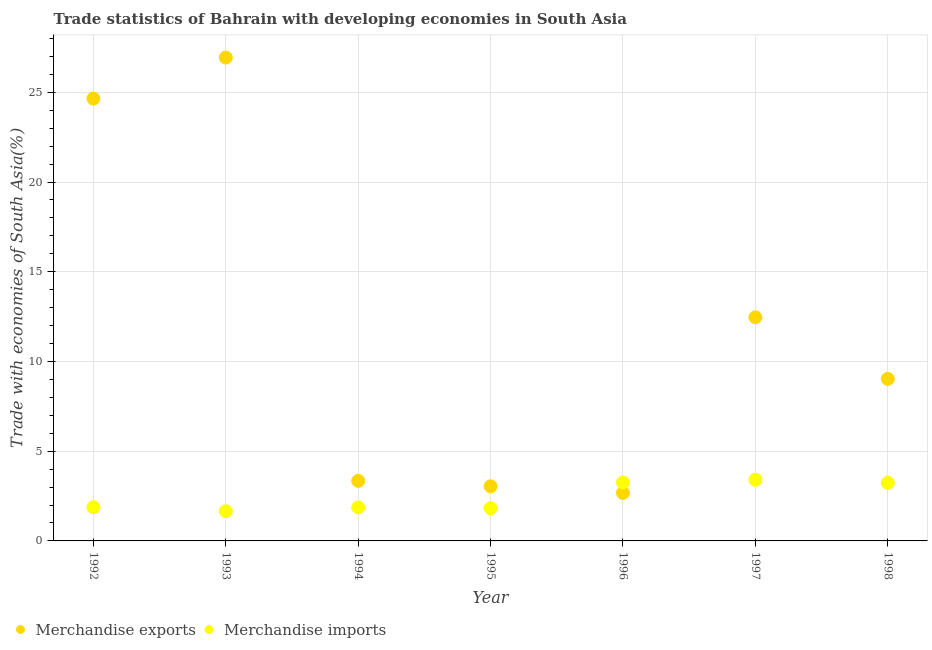How many different coloured dotlines are there?
Keep it short and to the point. 2. What is the merchandise imports in 1995?
Your answer should be very brief. 1.82. Across all years, what is the maximum merchandise exports?
Your answer should be compact. 26.94. Across all years, what is the minimum merchandise exports?
Provide a short and direct response. 2.67. What is the total merchandise exports in the graph?
Provide a short and direct response. 82.15. What is the difference between the merchandise imports in 1993 and that in 1994?
Keep it short and to the point. -0.21. What is the difference between the merchandise imports in 1997 and the merchandise exports in 1992?
Offer a very short reply. -21.24. What is the average merchandise exports per year?
Your answer should be very brief. 11.74. In the year 1993, what is the difference between the merchandise imports and merchandise exports?
Ensure brevity in your answer.  -25.28. What is the ratio of the merchandise exports in 1996 to that in 1997?
Keep it short and to the point. 0.21. Is the merchandise imports in 1995 less than that in 1997?
Keep it short and to the point. Yes. What is the difference between the highest and the second highest merchandise imports?
Provide a short and direct response. 0.15. What is the difference between the highest and the lowest merchandise exports?
Make the answer very short. 24.26. In how many years, is the merchandise exports greater than the average merchandise exports taken over all years?
Provide a succinct answer. 3. Does the merchandise exports monotonically increase over the years?
Offer a terse response. No. Is the merchandise exports strictly greater than the merchandise imports over the years?
Give a very brief answer. No. Does the graph contain grids?
Your response must be concise. Yes. Where does the legend appear in the graph?
Your answer should be very brief. Bottom left. How are the legend labels stacked?
Offer a terse response. Horizontal. What is the title of the graph?
Make the answer very short. Trade statistics of Bahrain with developing economies in South Asia. What is the label or title of the Y-axis?
Offer a very short reply. Trade with economies of South Asia(%). What is the Trade with economies of South Asia(%) in Merchandise exports in 1992?
Make the answer very short. 24.65. What is the Trade with economies of South Asia(%) in Merchandise imports in 1992?
Your response must be concise. 1.88. What is the Trade with economies of South Asia(%) in Merchandise exports in 1993?
Make the answer very short. 26.94. What is the Trade with economies of South Asia(%) of Merchandise imports in 1993?
Provide a short and direct response. 1.65. What is the Trade with economies of South Asia(%) of Merchandise exports in 1994?
Offer a very short reply. 3.35. What is the Trade with economies of South Asia(%) in Merchandise imports in 1994?
Ensure brevity in your answer.  1.87. What is the Trade with economies of South Asia(%) in Merchandise exports in 1995?
Your answer should be very brief. 3.04. What is the Trade with economies of South Asia(%) of Merchandise imports in 1995?
Keep it short and to the point. 1.82. What is the Trade with economies of South Asia(%) in Merchandise exports in 1996?
Your answer should be very brief. 2.67. What is the Trade with economies of South Asia(%) in Merchandise imports in 1996?
Ensure brevity in your answer.  3.26. What is the Trade with economies of South Asia(%) of Merchandise exports in 1997?
Ensure brevity in your answer.  12.46. What is the Trade with economies of South Asia(%) in Merchandise imports in 1997?
Your answer should be compact. 3.41. What is the Trade with economies of South Asia(%) of Merchandise exports in 1998?
Your response must be concise. 9.03. What is the Trade with economies of South Asia(%) in Merchandise imports in 1998?
Keep it short and to the point. 3.24. Across all years, what is the maximum Trade with economies of South Asia(%) of Merchandise exports?
Provide a succinct answer. 26.94. Across all years, what is the maximum Trade with economies of South Asia(%) of Merchandise imports?
Offer a very short reply. 3.41. Across all years, what is the minimum Trade with economies of South Asia(%) of Merchandise exports?
Provide a short and direct response. 2.67. Across all years, what is the minimum Trade with economies of South Asia(%) in Merchandise imports?
Offer a very short reply. 1.65. What is the total Trade with economies of South Asia(%) in Merchandise exports in the graph?
Provide a short and direct response. 82.15. What is the total Trade with economies of South Asia(%) of Merchandise imports in the graph?
Ensure brevity in your answer.  17.13. What is the difference between the Trade with economies of South Asia(%) in Merchandise exports in 1992 and that in 1993?
Offer a very short reply. -2.29. What is the difference between the Trade with economies of South Asia(%) in Merchandise imports in 1992 and that in 1993?
Provide a succinct answer. 0.23. What is the difference between the Trade with economies of South Asia(%) of Merchandise exports in 1992 and that in 1994?
Keep it short and to the point. 21.3. What is the difference between the Trade with economies of South Asia(%) of Merchandise imports in 1992 and that in 1994?
Keep it short and to the point. 0.01. What is the difference between the Trade with economies of South Asia(%) of Merchandise exports in 1992 and that in 1995?
Provide a short and direct response. 21.6. What is the difference between the Trade with economies of South Asia(%) in Merchandise imports in 1992 and that in 1995?
Offer a very short reply. 0.06. What is the difference between the Trade with economies of South Asia(%) of Merchandise exports in 1992 and that in 1996?
Your response must be concise. 21.97. What is the difference between the Trade with economies of South Asia(%) of Merchandise imports in 1992 and that in 1996?
Provide a short and direct response. -1.38. What is the difference between the Trade with economies of South Asia(%) in Merchandise exports in 1992 and that in 1997?
Provide a short and direct response. 12.19. What is the difference between the Trade with economies of South Asia(%) of Merchandise imports in 1992 and that in 1997?
Your response must be concise. -1.53. What is the difference between the Trade with economies of South Asia(%) in Merchandise exports in 1992 and that in 1998?
Provide a succinct answer. 15.62. What is the difference between the Trade with economies of South Asia(%) of Merchandise imports in 1992 and that in 1998?
Keep it short and to the point. -1.36. What is the difference between the Trade with economies of South Asia(%) of Merchandise exports in 1993 and that in 1994?
Ensure brevity in your answer.  23.59. What is the difference between the Trade with economies of South Asia(%) in Merchandise imports in 1993 and that in 1994?
Keep it short and to the point. -0.21. What is the difference between the Trade with economies of South Asia(%) in Merchandise exports in 1993 and that in 1995?
Offer a terse response. 23.89. What is the difference between the Trade with economies of South Asia(%) of Merchandise imports in 1993 and that in 1995?
Make the answer very short. -0.17. What is the difference between the Trade with economies of South Asia(%) in Merchandise exports in 1993 and that in 1996?
Offer a very short reply. 24.26. What is the difference between the Trade with economies of South Asia(%) in Merchandise imports in 1993 and that in 1996?
Your answer should be compact. -1.61. What is the difference between the Trade with economies of South Asia(%) in Merchandise exports in 1993 and that in 1997?
Ensure brevity in your answer.  14.47. What is the difference between the Trade with economies of South Asia(%) in Merchandise imports in 1993 and that in 1997?
Ensure brevity in your answer.  -1.75. What is the difference between the Trade with economies of South Asia(%) in Merchandise exports in 1993 and that in 1998?
Make the answer very short. 17.91. What is the difference between the Trade with economies of South Asia(%) in Merchandise imports in 1993 and that in 1998?
Your answer should be very brief. -1.58. What is the difference between the Trade with economies of South Asia(%) in Merchandise exports in 1994 and that in 1995?
Offer a terse response. 0.3. What is the difference between the Trade with economies of South Asia(%) of Merchandise imports in 1994 and that in 1995?
Offer a terse response. 0.05. What is the difference between the Trade with economies of South Asia(%) of Merchandise exports in 1994 and that in 1996?
Your response must be concise. 0.67. What is the difference between the Trade with economies of South Asia(%) of Merchandise imports in 1994 and that in 1996?
Your answer should be very brief. -1.39. What is the difference between the Trade with economies of South Asia(%) in Merchandise exports in 1994 and that in 1997?
Provide a short and direct response. -9.11. What is the difference between the Trade with economies of South Asia(%) of Merchandise imports in 1994 and that in 1997?
Provide a succinct answer. -1.54. What is the difference between the Trade with economies of South Asia(%) of Merchandise exports in 1994 and that in 1998?
Keep it short and to the point. -5.68. What is the difference between the Trade with economies of South Asia(%) in Merchandise imports in 1994 and that in 1998?
Provide a short and direct response. -1.37. What is the difference between the Trade with economies of South Asia(%) in Merchandise exports in 1995 and that in 1996?
Offer a very short reply. 0.37. What is the difference between the Trade with economies of South Asia(%) in Merchandise imports in 1995 and that in 1996?
Your response must be concise. -1.44. What is the difference between the Trade with economies of South Asia(%) in Merchandise exports in 1995 and that in 1997?
Offer a terse response. -9.42. What is the difference between the Trade with economies of South Asia(%) in Merchandise imports in 1995 and that in 1997?
Offer a terse response. -1.59. What is the difference between the Trade with economies of South Asia(%) of Merchandise exports in 1995 and that in 1998?
Provide a succinct answer. -5.99. What is the difference between the Trade with economies of South Asia(%) in Merchandise imports in 1995 and that in 1998?
Make the answer very short. -1.41. What is the difference between the Trade with economies of South Asia(%) in Merchandise exports in 1996 and that in 1997?
Your response must be concise. -9.79. What is the difference between the Trade with economies of South Asia(%) in Merchandise imports in 1996 and that in 1997?
Your answer should be compact. -0.15. What is the difference between the Trade with economies of South Asia(%) in Merchandise exports in 1996 and that in 1998?
Your answer should be very brief. -6.36. What is the difference between the Trade with economies of South Asia(%) in Merchandise imports in 1996 and that in 1998?
Make the answer very short. 0.02. What is the difference between the Trade with economies of South Asia(%) in Merchandise exports in 1997 and that in 1998?
Give a very brief answer. 3.43. What is the difference between the Trade with economies of South Asia(%) of Merchandise imports in 1997 and that in 1998?
Give a very brief answer. 0.17. What is the difference between the Trade with economies of South Asia(%) of Merchandise exports in 1992 and the Trade with economies of South Asia(%) of Merchandise imports in 1993?
Ensure brevity in your answer.  23. What is the difference between the Trade with economies of South Asia(%) of Merchandise exports in 1992 and the Trade with economies of South Asia(%) of Merchandise imports in 1994?
Ensure brevity in your answer.  22.78. What is the difference between the Trade with economies of South Asia(%) of Merchandise exports in 1992 and the Trade with economies of South Asia(%) of Merchandise imports in 1995?
Provide a succinct answer. 22.83. What is the difference between the Trade with economies of South Asia(%) of Merchandise exports in 1992 and the Trade with economies of South Asia(%) of Merchandise imports in 1996?
Provide a succinct answer. 21.39. What is the difference between the Trade with economies of South Asia(%) in Merchandise exports in 1992 and the Trade with economies of South Asia(%) in Merchandise imports in 1997?
Keep it short and to the point. 21.24. What is the difference between the Trade with economies of South Asia(%) in Merchandise exports in 1992 and the Trade with economies of South Asia(%) in Merchandise imports in 1998?
Give a very brief answer. 21.41. What is the difference between the Trade with economies of South Asia(%) in Merchandise exports in 1993 and the Trade with economies of South Asia(%) in Merchandise imports in 1994?
Offer a terse response. 25.07. What is the difference between the Trade with economies of South Asia(%) in Merchandise exports in 1993 and the Trade with economies of South Asia(%) in Merchandise imports in 1995?
Give a very brief answer. 25.11. What is the difference between the Trade with economies of South Asia(%) of Merchandise exports in 1993 and the Trade with economies of South Asia(%) of Merchandise imports in 1996?
Ensure brevity in your answer.  23.68. What is the difference between the Trade with economies of South Asia(%) in Merchandise exports in 1993 and the Trade with economies of South Asia(%) in Merchandise imports in 1997?
Keep it short and to the point. 23.53. What is the difference between the Trade with economies of South Asia(%) in Merchandise exports in 1993 and the Trade with economies of South Asia(%) in Merchandise imports in 1998?
Provide a short and direct response. 23.7. What is the difference between the Trade with economies of South Asia(%) of Merchandise exports in 1994 and the Trade with economies of South Asia(%) of Merchandise imports in 1995?
Ensure brevity in your answer.  1.53. What is the difference between the Trade with economies of South Asia(%) in Merchandise exports in 1994 and the Trade with economies of South Asia(%) in Merchandise imports in 1996?
Your answer should be compact. 0.09. What is the difference between the Trade with economies of South Asia(%) of Merchandise exports in 1994 and the Trade with economies of South Asia(%) of Merchandise imports in 1997?
Your answer should be compact. -0.06. What is the difference between the Trade with economies of South Asia(%) in Merchandise exports in 1994 and the Trade with economies of South Asia(%) in Merchandise imports in 1998?
Make the answer very short. 0.11. What is the difference between the Trade with economies of South Asia(%) of Merchandise exports in 1995 and the Trade with economies of South Asia(%) of Merchandise imports in 1996?
Your answer should be very brief. -0.21. What is the difference between the Trade with economies of South Asia(%) in Merchandise exports in 1995 and the Trade with economies of South Asia(%) in Merchandise imports in 1997?
Provide a succinct answer. -0.36. What is the difference between the Trade with economies of South Asia(%) in Merchandise exports in 1995 and the Trade with economies of South Asia(%) in Merchandise imports in 1998?
Your answer should be very brief. -0.19. What is the difference between the Trade with economies of South Asia(%) in Merchandise exports in 1996 and the Trade with economies of South Asia(%) in Merchandise imports in 1997?
Give a very brief answer. -0.73. What is the difference between the Trade with economies of South Asia(%) of Merchandise exports in 1996 and the Trade with economies of South Asia(%) of Merchandise imports in 1998?
Provide a succinct answer. -0.56. What is the difference between the Trade with economies of South Asia(%) of Merchandise exports in 1997 and the Trade with economies of South Asia(%) of Merchandise imports in 1998?
Offer a terse response. 9.23. What is the average Trade with economies of South Asia(%) of Merchandise exports per year?
Keep it short and to the point. 11.74. What is the average Trade with economies of South Asia(%) in Merchandise imports per year?
Your answer should be compact. 2.45. In the year 1992, what is the difference between the Trade with economies of South Asia(%) in Merchandise exports and Trade with economies of South Asia(%) in Merchandise imports?
Ensure brevity in your answer.  22.77. In the year 1993, what is the difference between the Trade with economies of South Asia(%) in Merchandise exports and Trade with economies of South Asia(%) in Merchandise imports?
Keep it short and to the point. 25.28. In the year 1994, what is the difference between the Trade with economies of South Asia(%) in Merchandise exports and Trade with economies of South Asia(%) in Merchandise imports?
Offer a terse response. 1.48. In the year 1995, what is the difference between the Trade with economies of South Asia(%) in Merchandise exports and Trade with economies of South Asia(%) in Merchandise imports?
Make the answer very short. 1.22. In the year 1996, what is the difference between the Trade with economies of South Asia(%) in Merchandise exports and Trade with economies of South Asia(%) in Merchandise imports?
Your answer should be compact. -0.58. In the year 1997, what is the difference between the Trade with economies of South Asia(%) of Merchandise exports and Trade with economies of South Asia(%) of Merchandise imports?
Provide a succinct answer. 9.06. In the year 1998, what is the difference between the Trade with economies of South Asia(%) in Merchandise exports and Trade with economies of South Asia(%) in Merchandise imports?
Make the answer very short. 5.79. What is the ratio of the Trade with economies of South Asia(%) of Merchandise exports in 1992 to that in 1993?
Offer a very short reply. 0.92. What is the ratio of the Trade with economies of South Asia(%) of Merchandise imports in 1992 to that in 1993?
Provide a short and direct response. 1.14. What is the ratio of the Trade with economies of South Asia(%) in Merchandise exports in 1992 to that in 1994?
Keep it short and to the point. 7.36. What is the ratio of the Trade with economies of South Asia(%) in Merchandise imports in 1992 to that in 1994?
Provide a succinct answer. 1.01. What is the ratio of the Trade with economies of South Asia(%) of Merchandise exports in 1992 to that in 1995?
Your answer should be compact. 8.1. What is the ratio of the Trade with economies of South Asia(%) in Merchandise imports in 1992 to that in 1995?
Keep it short and to the point. 1.03. What is the ratio of the Trade with economies of South Asia(%) of Merchandise exports in 1992 to that in 1996?
Give a very brief answer. 9.22. What is the ratio of the Trade with economies of South Asia(%) in Merchandise imports in 1992 to that in 1996?
Your response must be concise. 0.58. What is the ratio of the Trade with economies of South Asia(%) of Merchandise exports in 1992 to that in 1997?
Provide a succinct answer. 1.98. What is the ratio of the Trade with economies of South Asia(%) of Merchandise imports in 1992 to that in 1997?
Offer a terse response. 0.55. What is the ratio of the Trade with economies of South Asia(%) of Merchandise exports in 1992 to that in 1998?
Your answer should be very brief. 2.73. What is the ratio of the Trade with economies of South Asia(%) of Merchandise imports in 1992 to that in 1998?
Provide a short and direct response. 0.58. What is the ratio of the Trade with economies of South Asia(%) in Merchandise exports in 1993 to that in 1994?
Provide a short and direct response. 8.04. What is the ratio of the Trade with economies of South Asia(%) of Merchandise imports in 1993 to that in 1994?
Keep it short and to the point. 0.89. What is the ratio of the Trade with economies of South Asia(%) in Merchandise exports in 1993 to that in 1995?
Your response must be concise. 8.85. What is the ratio of the Trade with economies of South Asia(%) in Merchandise imports in 1993 to that in 1995?
Your answer should be compact. 0.91. What is the ratio of the Trade with economies of South Asia(%) in Merchandise exports in 1993 to that in 1996?
Your answer should be compact. 10.07. What is the ratio of the Trade with economies of South Asia(%) in Merchandise imports in 1993 to that in 1996?
Your answer should be very brief. 0.51. What is the ratio of the Trade with economies of South Asia(%) of Merchandise exports in 1993 to that in 1997?
Give a very brief answer. 2.16. What is the ratio of the Trade with economies of South Asia(%) in Merchandise imports in 1993 to that in 1997?
Provide a succinct answer. 0.49. What is the ratio of the Trade with economies of South Asia(%) of Merchandise exports in 1993 to that in 1998?
Provide a succinct answer. 2.98. What is the ratio of the Trade with economies of South Asia(%) in Merchandise imports in 1993 to that in 1998?
Your response must be concise. 0.51. What is the ratio of the Trade with economies of South Asia(%) in Merchandise exports in 1994 to that in 1995?
Ensure brevity in your answer.  1.1. What is the ratio of the Trade with economies of South Asia(%) in Merchandise imports in 1994 to that in 1995?
Ensure brevity in your answer.  1.02. What is the ratio of the Trade with economies of South Asia(%) in Merchandise exports in 1994 to that in 1996?
Provide a succinct answer. 1.25. What is the ratio of the Trade with economies of South Asia(%) of Merchandise imports in 1994 to that in 1996?
Give a very brief answer. 0.57. What is the ratio of the Trade with economies of South Asia(%) in Merchandise exports in 1994 to that in 1997?
Provide a succinct answer. 0.27. What is the ratio of the Trade with economies of South Asia(%) in Merchandise imports in 1994 to that in 1997?
Ensure brevity in your answer.  0.55. What is the ratio of the Trade with economies of South Asia(%) of Merchandise exports in 1994 to that in 1998?
Offer a terse response. 0.37. What is the ratio of the Trade with economies of South Asia(%) in Merchandise imports in 1994 to that in 1998?
Your response must be concise. 0.58. What is the ratio of the Trade with economies of South Asia(%) of Merchandise exports in 1995 to that in 1996?
Your response must be concise. 1.14. What is the ratio of the Trade with economies of South Asia(%) in Merchandise imports in 1995 to that in 1996?
Your response must be concise. 0.56. What is the ratio of the Trade with economies of South Asia(%) of Merchandise exports in 1995 to that in 1997?
Keep it short and to the point. 0.24. What is the ratio of the Trade with economies of South Asia(%) of Merchandise imports in 1995 to that in 1997?
Ensure brevity in your answer.  0.53. What is the ratio of the Trade with economies of South Asia(%) in Merchandise exports in 1995 to that in 1998?
Make the answer very short. 0.34. What is the ratio of the Trade with economies of South Asia(%) in Merchandise imports in 1995 to that in 1998?
Ensure brevity in your answer.  0.56. What is the ratio of the Trade with economies of South Asia(%) of Merchandise exports in 1996 to that in 1997?
Your answer should be very brief. 0.21. What is the ratio of the Trade with economies of South Asia(%) of Merchandise imports in 1996 to that in 1997?
Your answer should be compact. 0.96. What is the ratio of the Trade with economies of South Asia(%) of Merchandise exports in 1996 to that in 1998?
Your answer should be compact. 0.3. What is the ratio of the Trade with economies of South Asia(%) of Merchandise imports in 1996 to that in 1998?
Offer a terse response. 1.01. What is the ratio of the Trade with economies of South Asia(%) of Merchandise exports in 1997 to that in 1998?
Your answer should be very brief. 1.38. What is the ratio of the Trade with economies of South Asia(%) in Merchandise imports in 1997 to that in 1998?
Keep it short and to the point. 1.05. What is the difference between the highest and the second highest Trade with economies of South Asia(%) in Merchandise exports?
Give a very brief answer. 2.29. What is the difference between the highest and the second highest Trade with economies of South Asia(%) of Merchandise imports?
Provide a succinct answer. 0.15. What is the difference between the highest and the lowest Trade with economies of South Asia(%) of Merchandise exports?
Make the answer very short. 24.26. What is the difference between the highest and the lowest Trade with economies of South Asia(%) in Merchandise imports?
Offer a terse response. 1.75. 